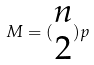Convert formula to latex. <formula><loc_0><loc_0><loc_500><loc_500>M = ( \begin{matrix} n \\ 2 \end{matrix} ) p</formula> 